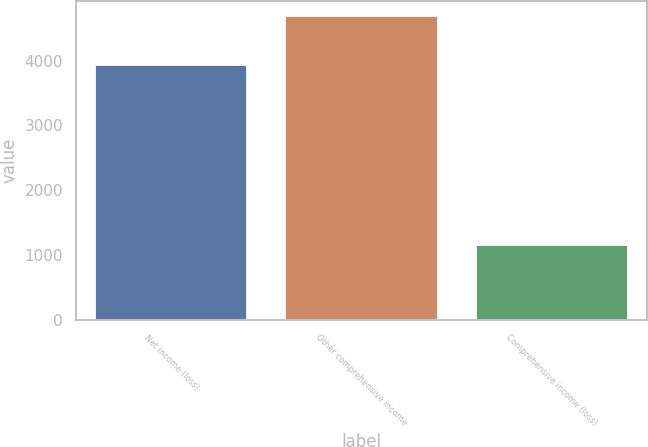Convert chart. <chart><loc_0><loc_0><loc_500><loc_500><bar_chart><fcel>Net income (loss)<fcel>Other comprehensive income<fcel>Comprehensive income (loss)<nl><fcel>3933<fcel>4689<fcel>1149.3<nl></chart> 